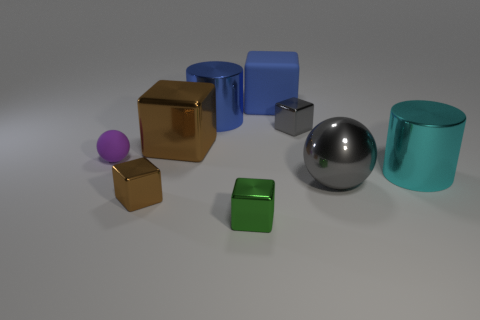Subtract all green blocks. How many blocks are left? 4 Subtract all gray blocks. How many blocks are left? 4 Subtract all yellow blocks. Subtract all green cylinders. How many blocks are left? 5 Add 1 tiny gray cubes. How many objects exist? 10 Subtract all cylinders. How many objects are left? 7 Subtract all large brown metallic things. Subtract all cyan rubber cylinders. How many objects are left? 8 Add 1 large brown metallic cubes. How many large brown metallic cubes are left? 2 Add 8 large balls. How many large balls exist? 9 Subtract 0 blue balls. How many objects are left? 9 